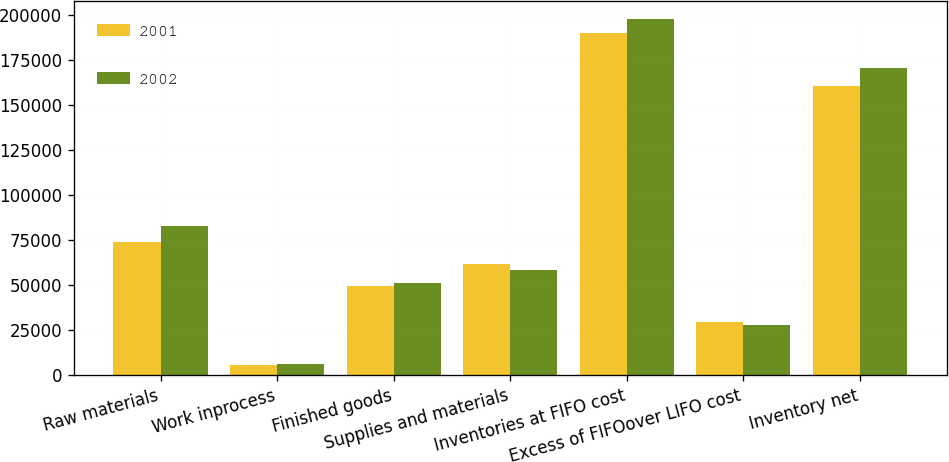Convert chart. <chart><loc_0><loc_0><loc_500><loc_500><stacked_bar_chart><ecel><fcel>Raw materials<fcel>Work inprocess<fcel>Finished goods<fcel>Supplies and materials<fcel>Inventories at FIFO cost<fcel>Excess of FIFOover LIFO cost<fcel>Inventory net<nl><fcel>2001<fcel>73730<fcel>5423<fcel>49306<fcel>61571<fcel>190030<fcel>29481<fcel>160549<nl><fcel>2002<fcel>82540<fcel>5989<fcel>51227<fcel>58118<fcel>197874<fcel>27701<fcel>170173<nl></chart> 